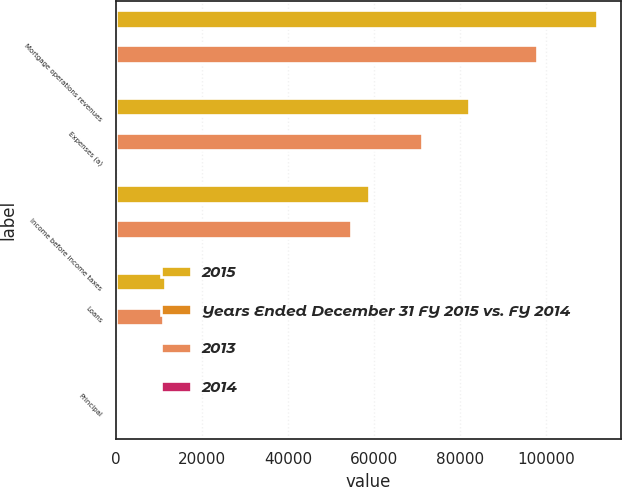Convert chart. <chart><loc_0><loc_0><loc_500><loc_500><stacked_bar_chart><ecel><fcel>Mortgage operations revenues<fcel>Expenses (a)<fcel>Income before income taxes<fcel>Loans<fcel>Principal<nl><fcel>2015<fcel>111810<fcel>82047<fcel>58706<fcel>11435<fcel>19<nl><fcel>Years Ended December 31 FY 2015 vs. FY 2014<fcel>14<fcel>15<fcel>8<fcel>6<fcel>10<nl><fcel>2013<fcel>97787<fcel>71057<fcel>54581<fcel>10805<fcel>19<nl><fcel>2014<fcel>14<fcel>23<fcel>12<fcel>9<fcel>4<nl></chart> 